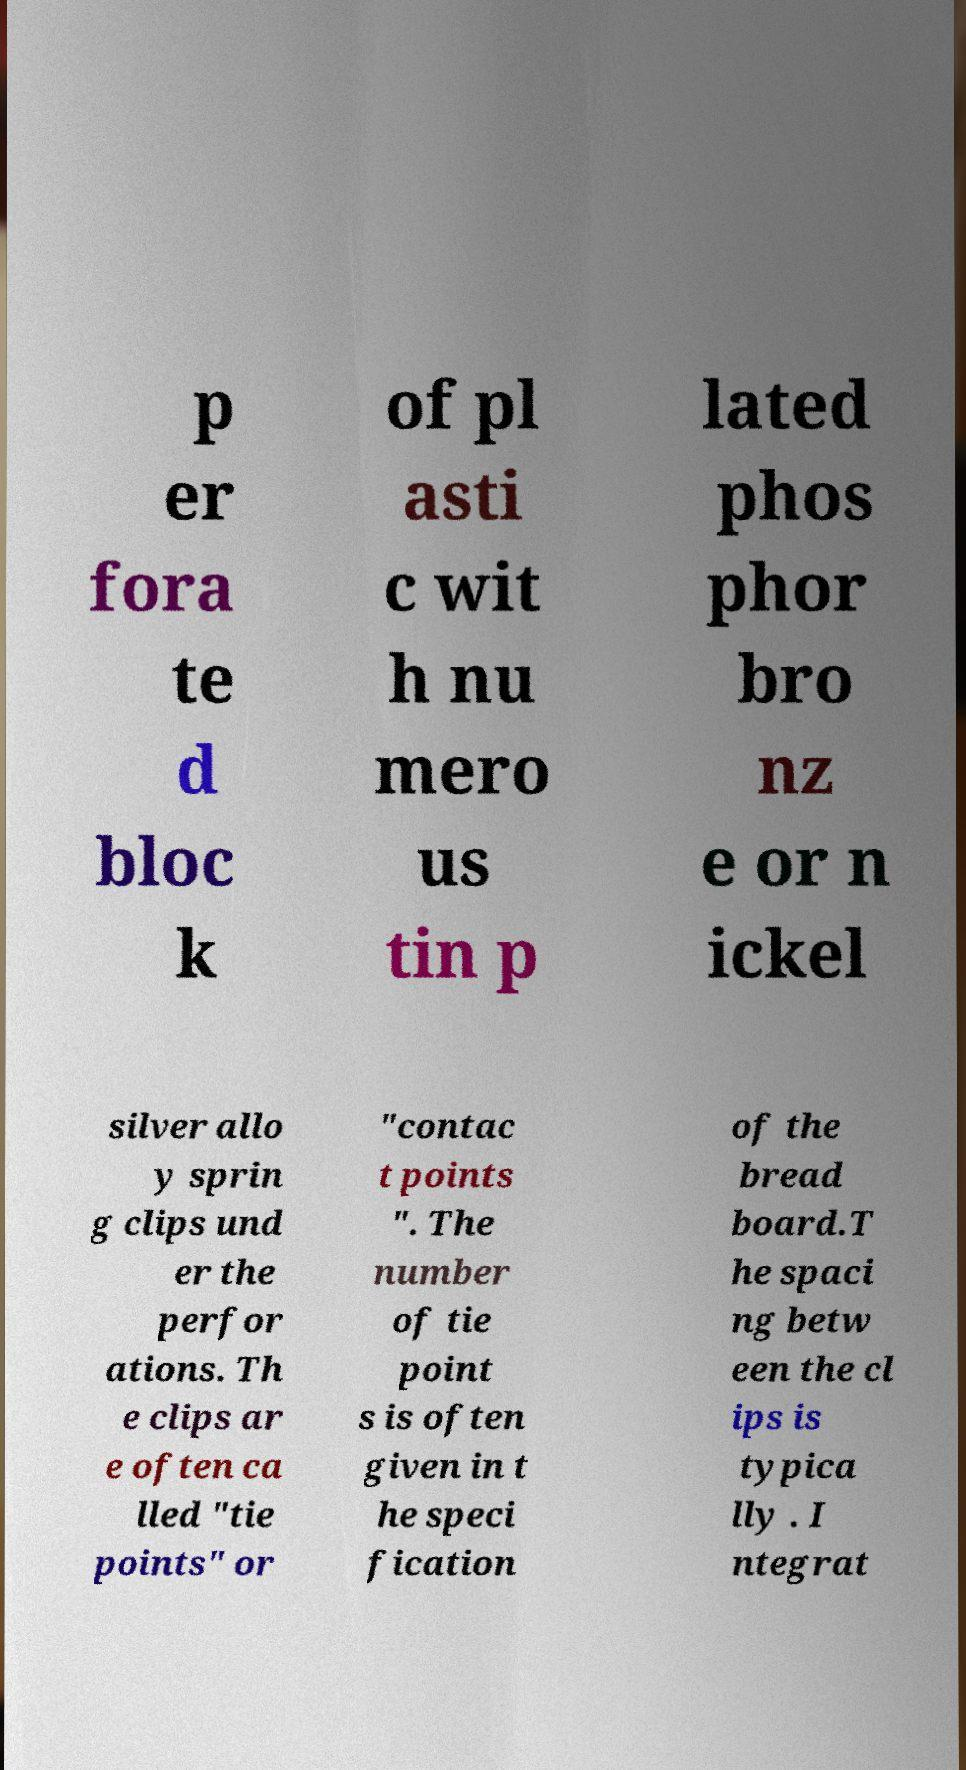What messages or text are displayed in this image? I need them in a readable, typed format. p er fora te d bloc k of pl asti c wit h nu mero us tin p lated phos phor bro nz e or n ickel silver allo y sprin g clips und er the perfor ations. Th e clips ar e often ca lled "tie points" or "contac t points ". The number of tie point s is often given in t he speci fication of the bread board.T he spaci ng betw een the cl ips is typica lly . I ntegrat 